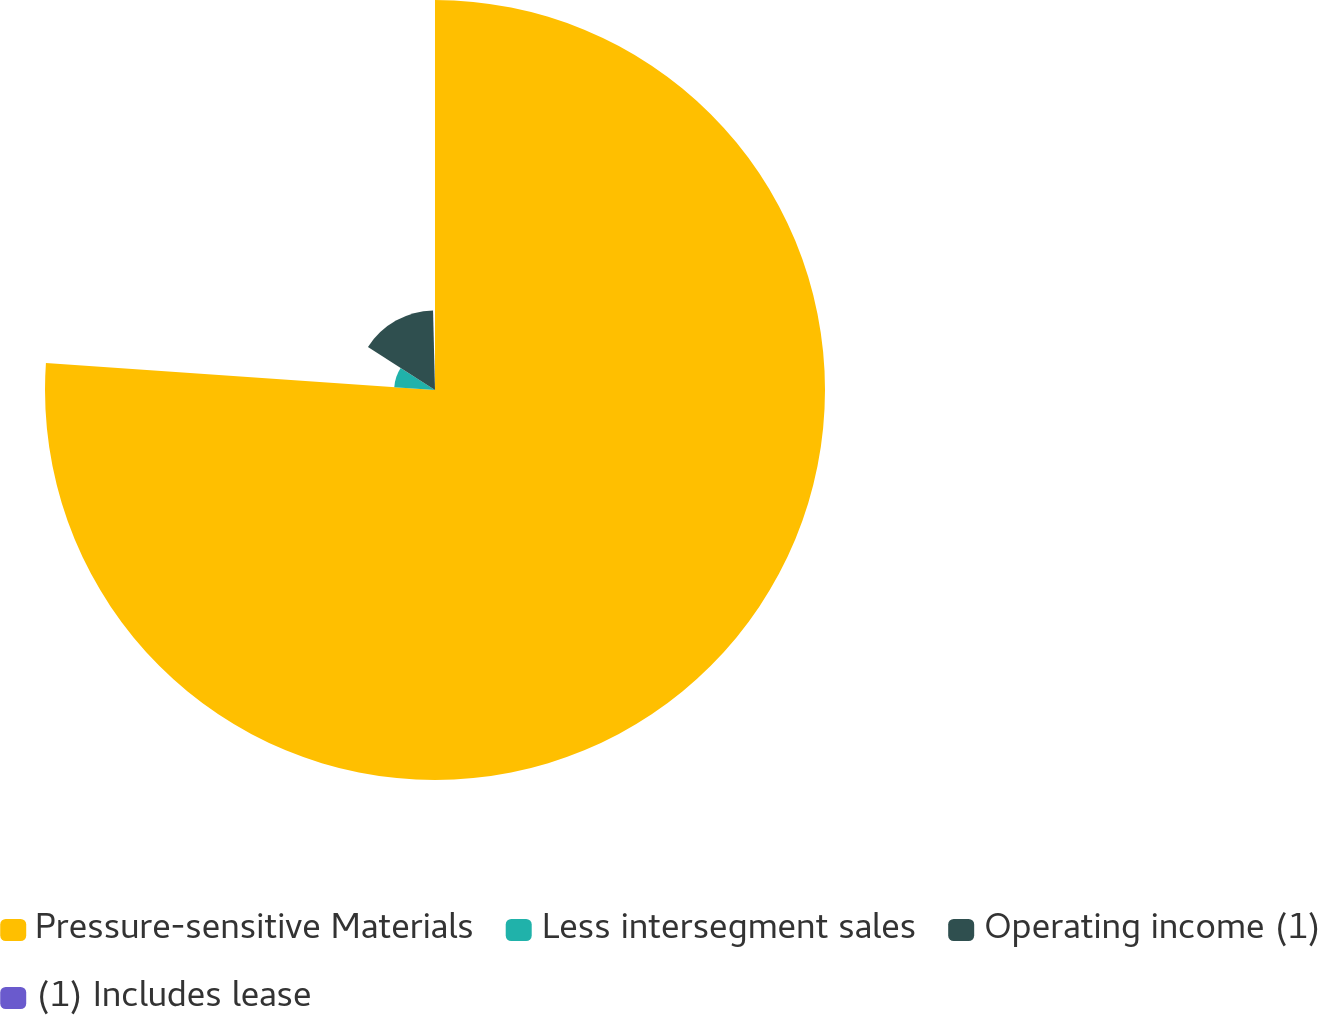<chart> <loc_0><loc_0><loc_500><loc_500><pie_chart><fcel>Pressure-sensitive Materials<fcel>Less intersegment sales<fcel>Operating income (1)<fcel>(1) Includes lease<nl><fcel>76.1%<fcel>7.97%<fcel>15.54%<fcel>0.39%<nl></chart> 